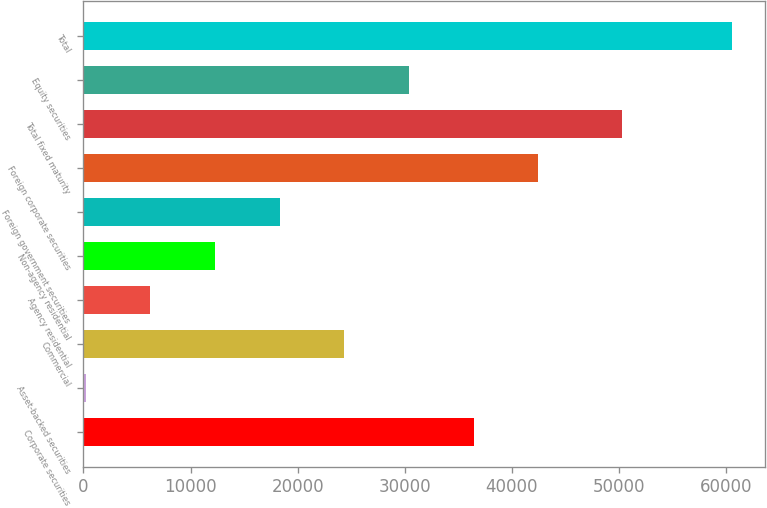Convert chart. <chart><loc_0><loc_0><loc_500><loc_500><bar_chart><fcel>Corporate securities<fcel>Asset-backed securities<fcel>Commercial<fcel>Agency residential<fcel>Non-agency residential<fcel>Foreign government securities<fcel>Foreign corporate securities<fcel>Total fixed maturity<fcel>Equity securities<fcel>Total<nl><fcel>36417.4<fcel>211<fcel>24348.6<fcel>6245.4<fcel>12279.8<fcel>18314.2<fcel>42451.8<fcel>50304<fcel>30383<fcel>60555<nl></chart> 